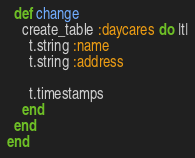Convert code to text. <code><loc_0><loc_0><loc_500><loc_500><_Ruby_>  def change
    create_table :daycares do |t|
      t.string :name
      t.string :address

      t.timestamps
    end
  end
end
</code> 